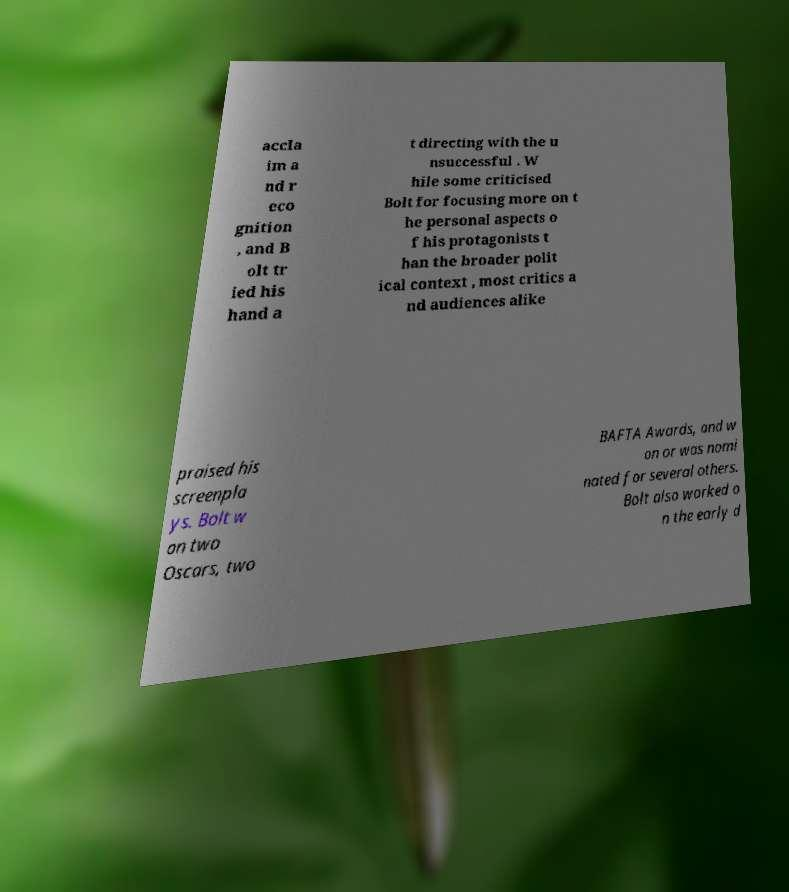Please read and relay the text visible in this image. What does it say? accla im a nd r eco gnition , and B olt tr ied his hand a t directing with the u nsuccessful . W hile some criticised Bolt for focusing more on t he personal aspects o f his protagonists t han the broader polit ical context , most critics a nd audiences alike praised his screenpla ys. Bolt w on two Oscars, two BAFTA Awards, and w on or was nomi nated for several others. Bolt also worked o n the early d 